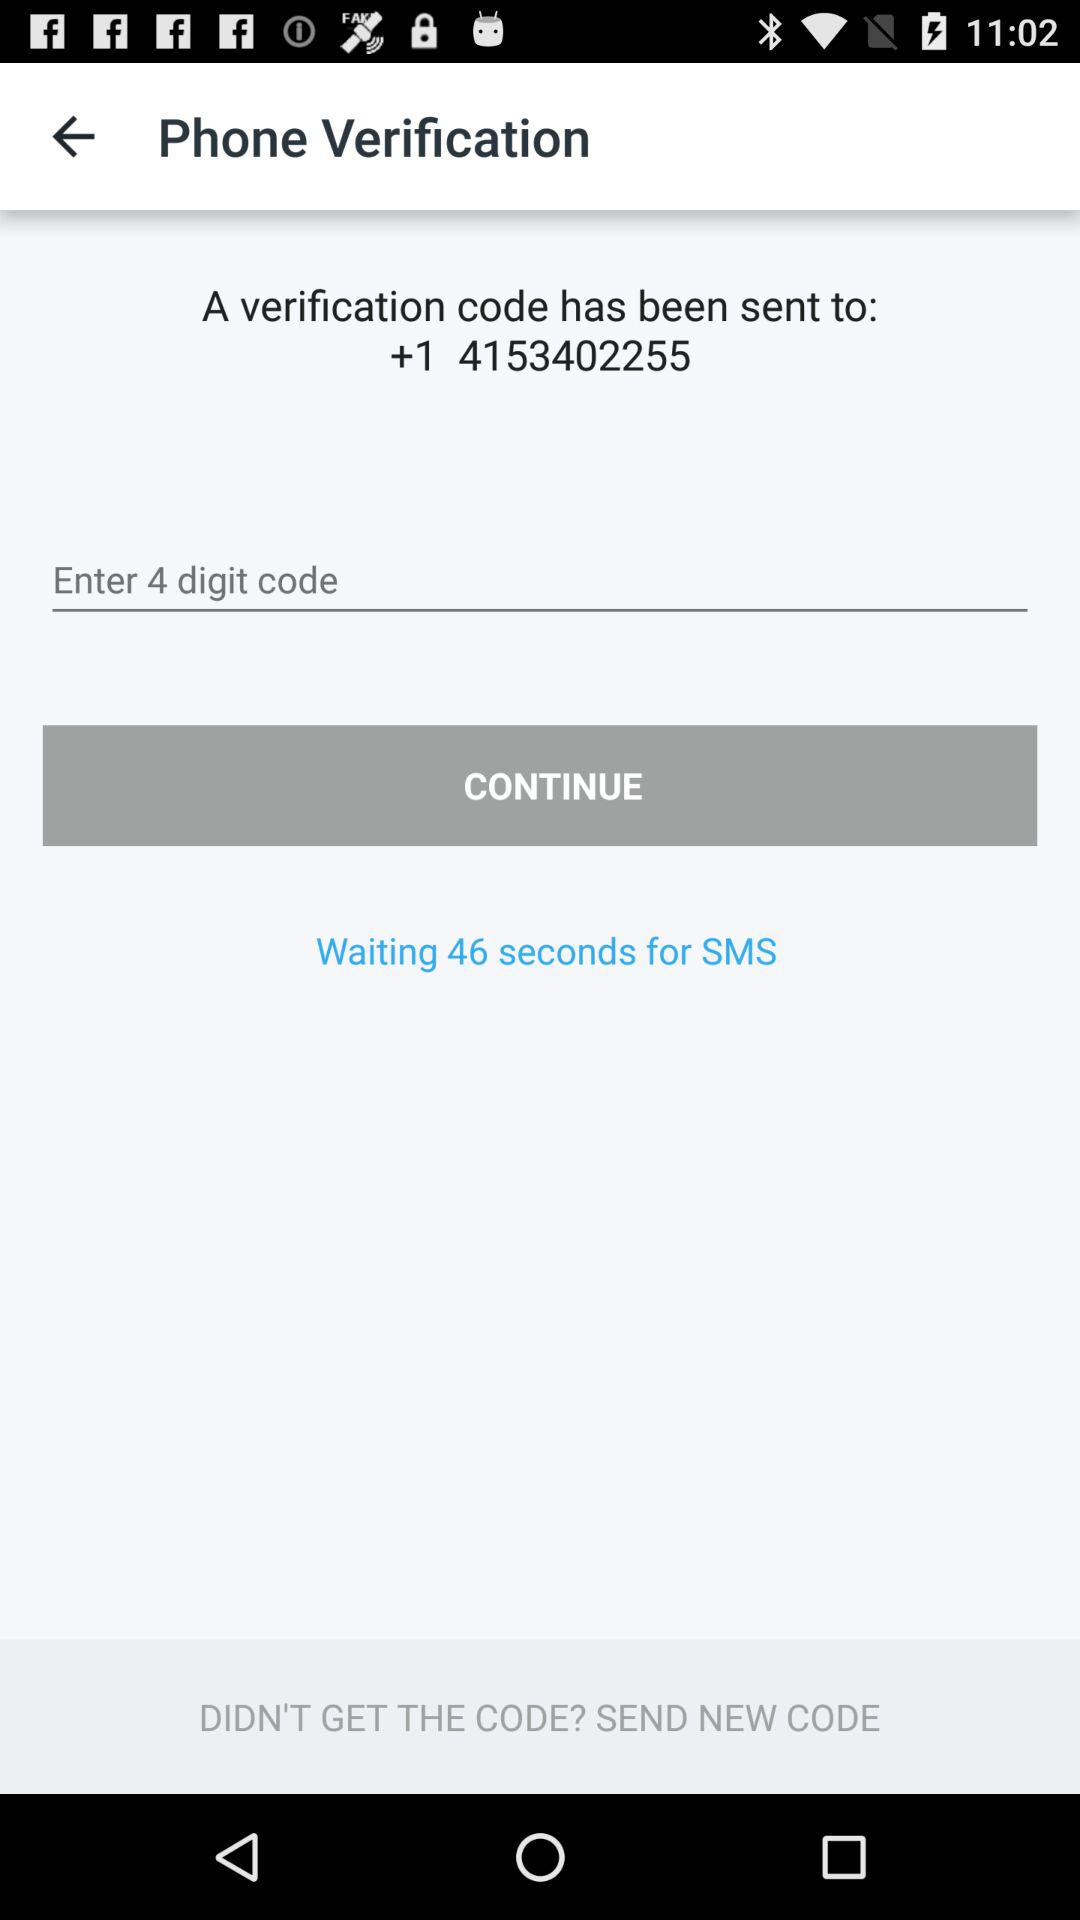What number has the verification code been sent to? The verification code has been sent to +1 4153402255. 